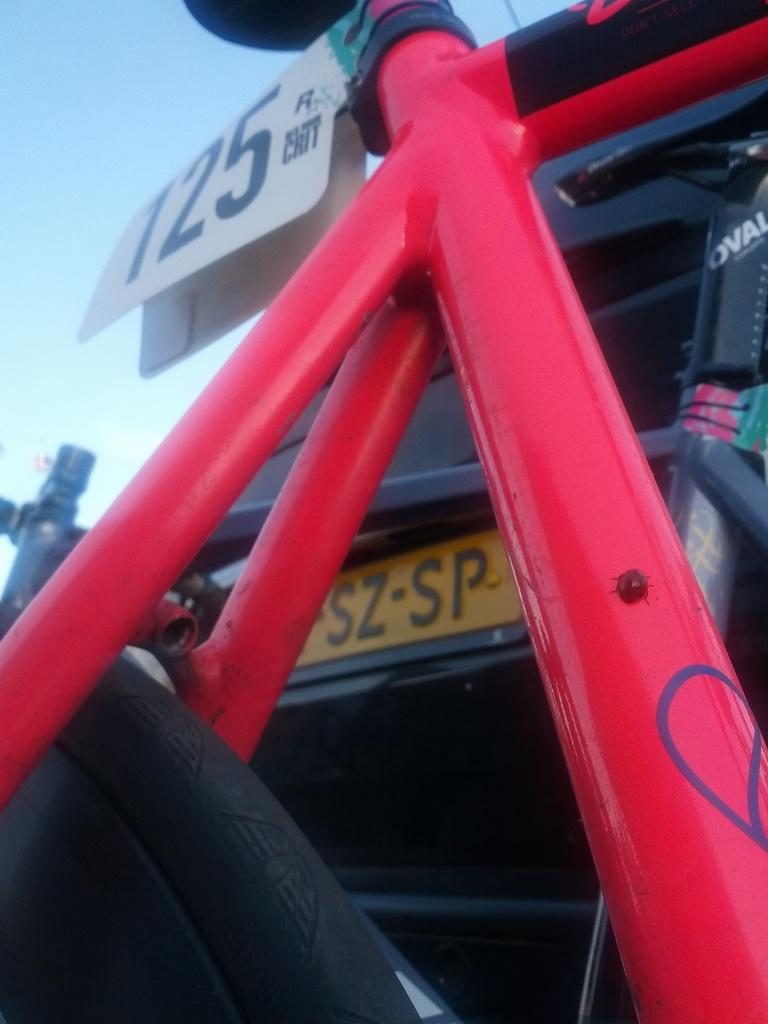What type of vehicle is the main subject in the image? There is a bicycle in the image. Can you describe any other vehicles or objects in the background? There is a car with a number plate in the background of the image. Is the existence of a stick in the image confirmed? There is no mention of a stick in the provided facts, so we cannot confirm its existence in the image. 